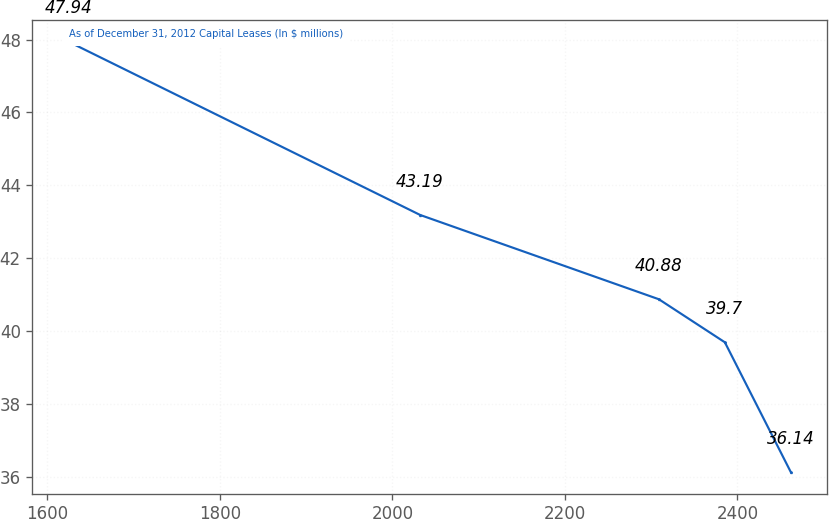Convert chart to OTSL. <chart><loc_0><loc_0><loc_500><loc_500><line_chart><ecel><fcel>As of December 31, 2012 Capital Leases (In $ millions)<nl><fcel>1624.78<fcel>47.94<nl><fcel>2032.28<fcel>43.19<nl><fcel>2308.9<fcel>40.88<nl><fcel>2385.37<fcel>39.7<nl><fcel>2461.84<fcel>36.14<nl></chart> 